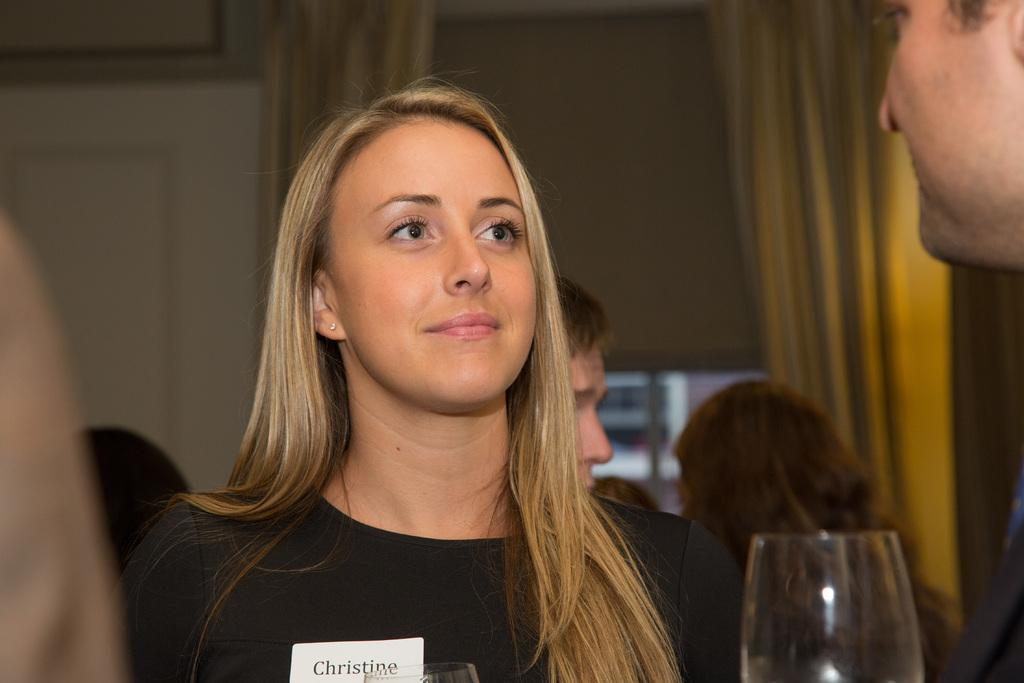Who is present in the image? There is a woman and a man in the image. What is the woman doing in the image? The woman is smiling in the image. How many people are standing in the image? There are people standing in the image, including the woman and the man. What can be seen on a surface in the image? There is a glass in the image. What type of electronic devices are visible in the image? There are monitors in the image. What type of window treatment is present in the image? There are curtains in the image. What type of story is being told by the lizards in the image? There are no lizards present in the image, so no story can be told by them. Can you describe the robin's nest in the image? There is no robin or nest present in the image. 